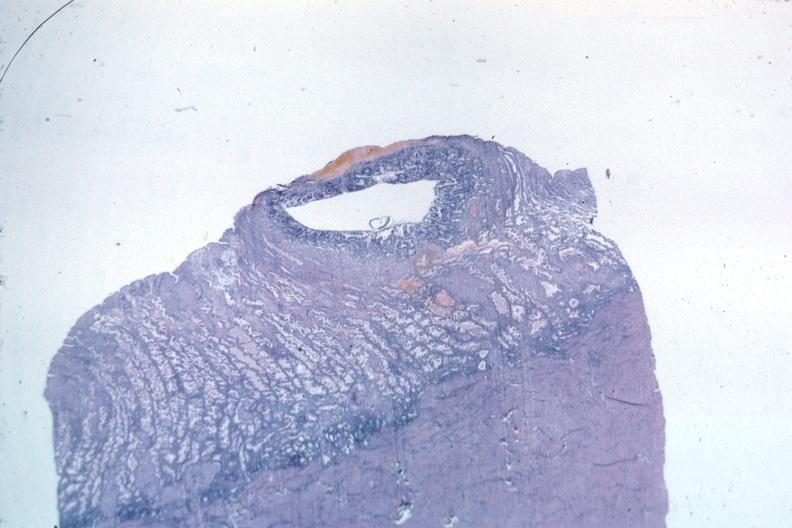what is present?
Answer the question using a single word or phrase. Female reproductive 